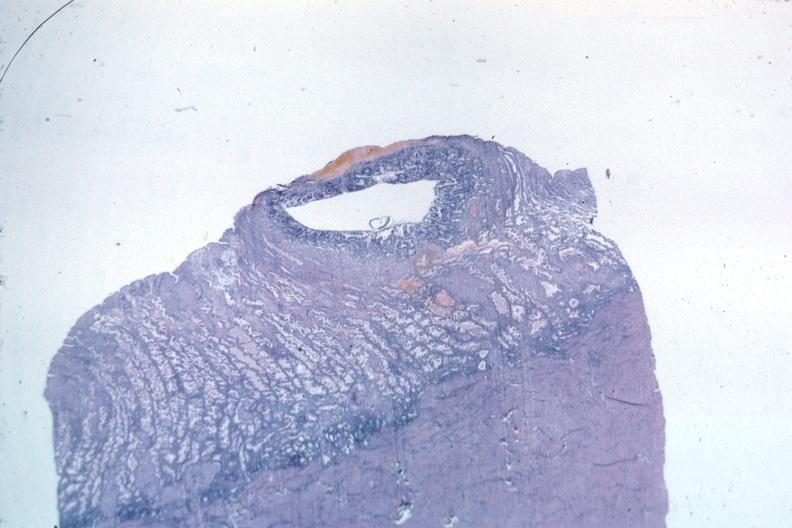what is present?
Answer the question using a single word or phrase. Female reproductive 